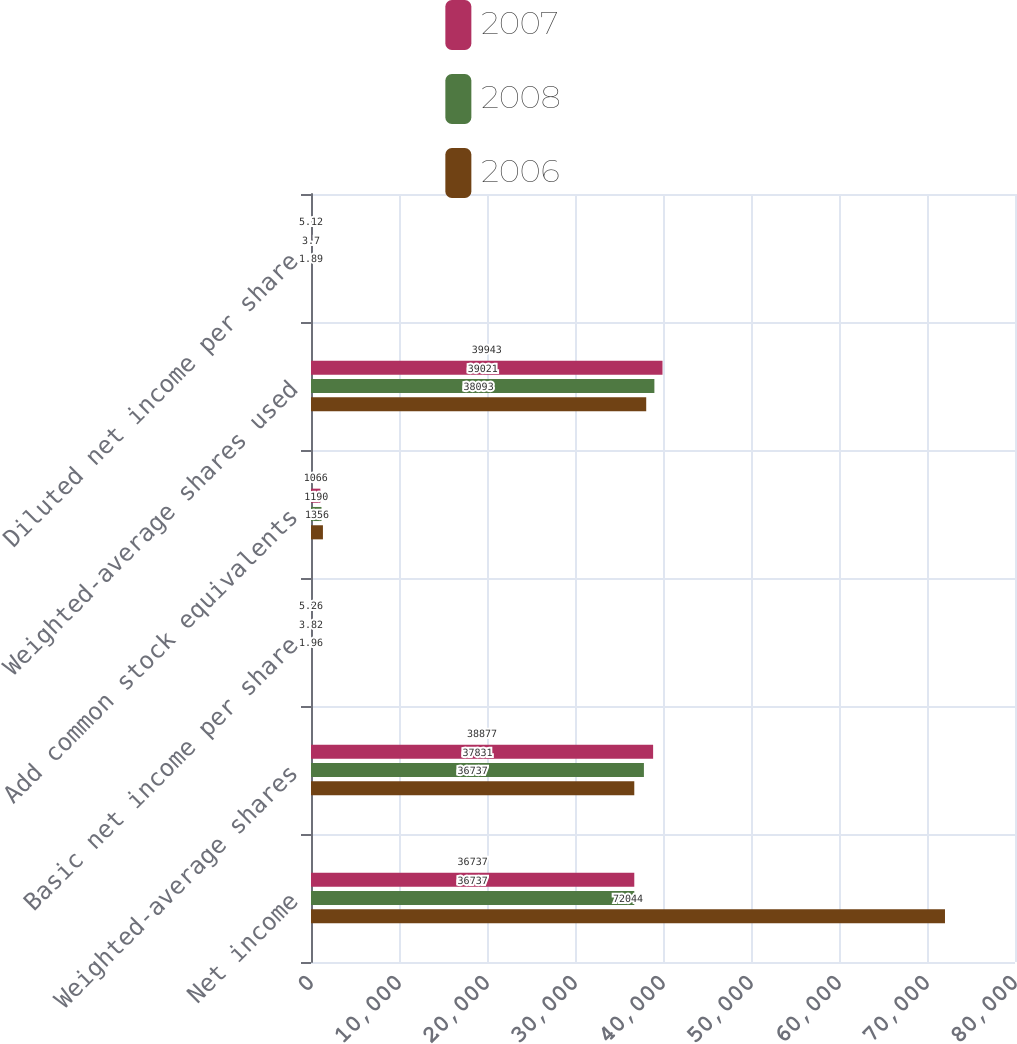Convert chart. <chart><loc_0><loc_0><loc_500><loc_500><stacked_bar_chart><ecel><fcel>Net income<fcel>Weighted-average shares<fcel>Basic net income per share<fcel>Add common stock equivalents<fcel>Weighted-average shares used<fcel>Diluted net income per share<nl><fcel>2007<fcel>36737<fcel>38877<fcel>5.26<fcel>1066<fcel>39943<fcel>5.12<nl><fcel>2008<fcel>36737<fcel>37831<fcel>3.82<fcel>1190<fcel>39021<fcel>3.7<nl><fcel>2006<fcel>72044<fcel>36737<fcel>1.96<fcel>1356<fcel>38093<fcel>1.89<nl></chart> 